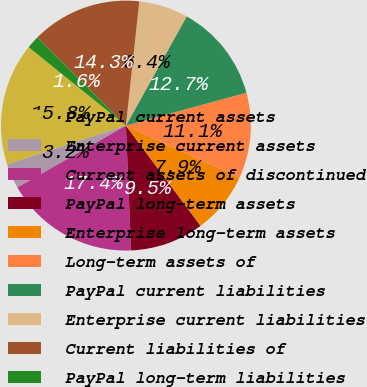Convert chart. <chart><loc_0><loc_0><loc_500><loc_500><pie_chart><fcel>PayPal current assets<fcel>Enterprise current assets<fcel>Current assets of discontinued<fcel>PayPal long-term assets<fcel>Enterprise long-term assets<fcel>Long-term assets of<fcel>PayPal current liabilities<fcel>Enterprise current liabilities<fcel>Current liabilities of<fcel>PayPal long-term liabilities<nl><fcel>15.83%<fcel>3.22%<fcel>17.41%<fcel>9.53%<fcel>7.95%<fcel>11.1%<fcel>12.68%<fcel>6.37%<fcel>14.26%<fcel>1.65%<nl></chart> 